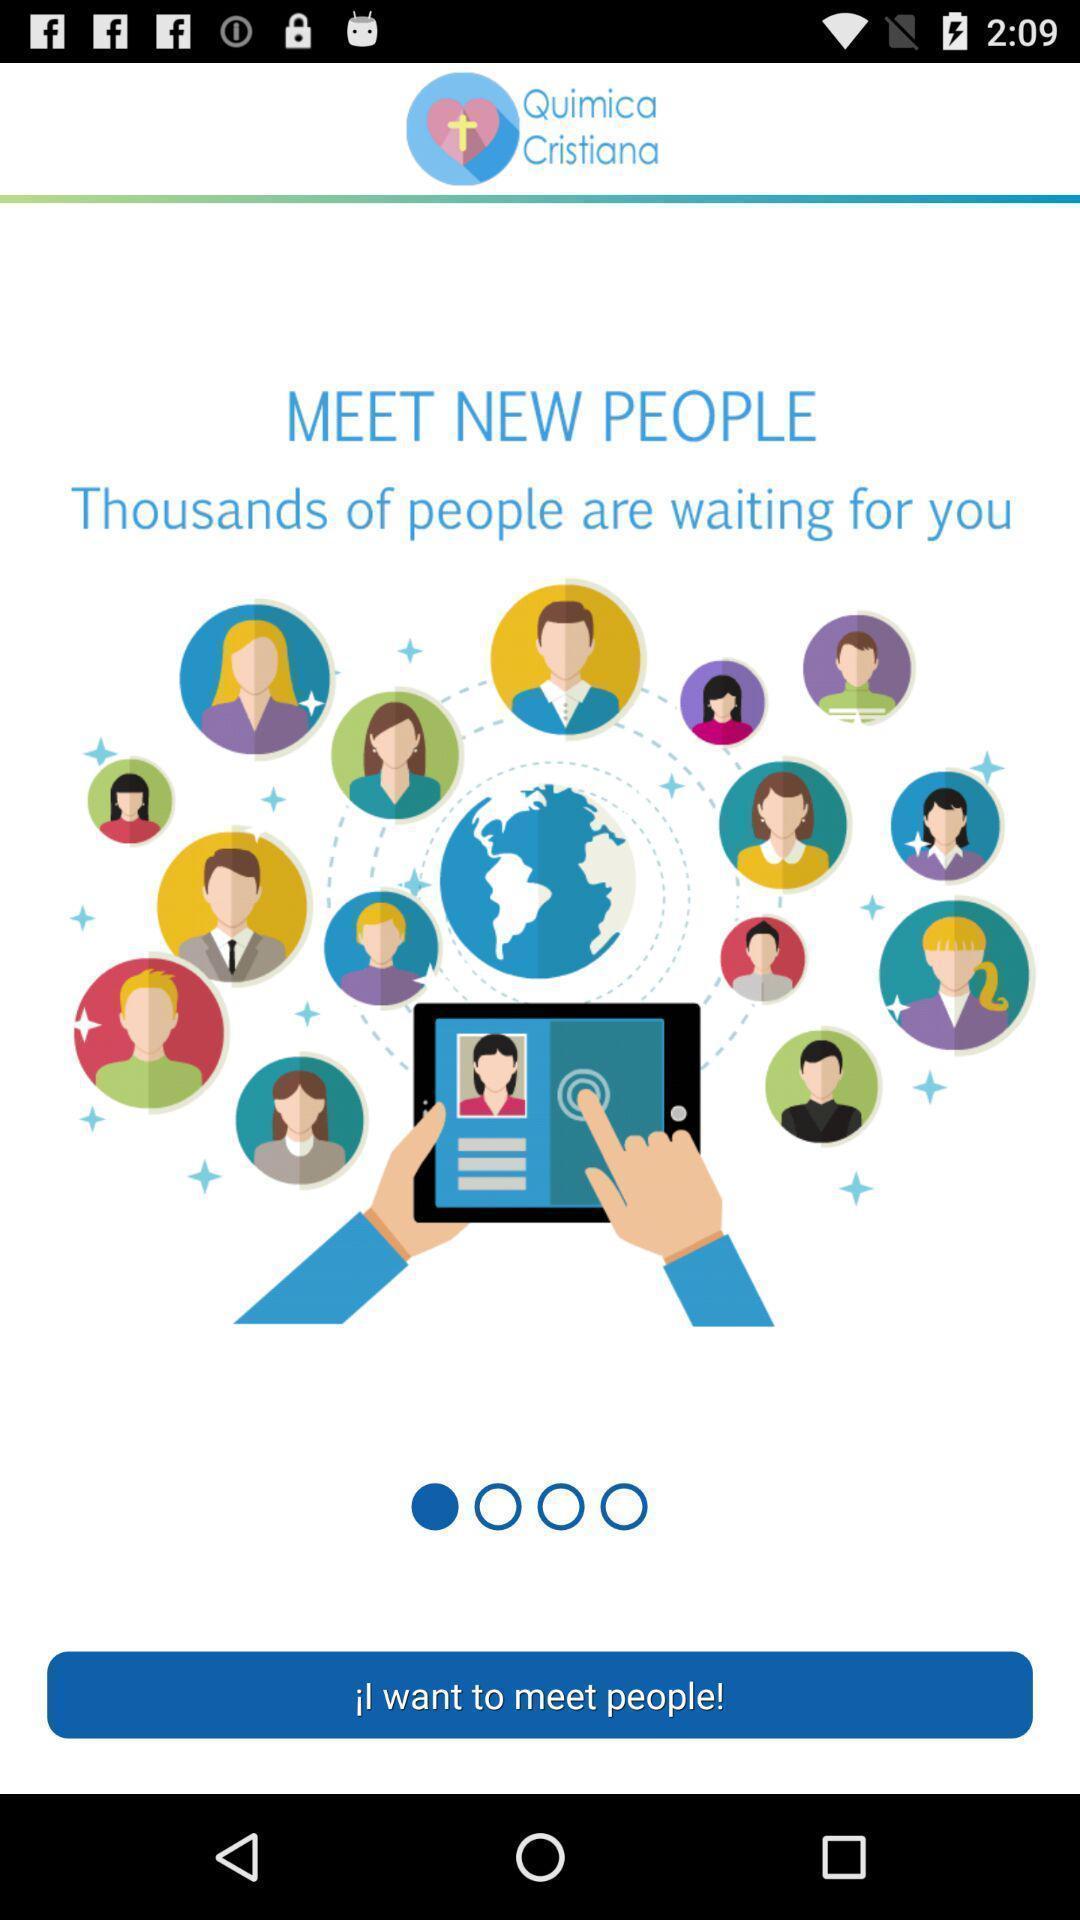What is the overall content of this screenshot? Welcome page of the social app. 